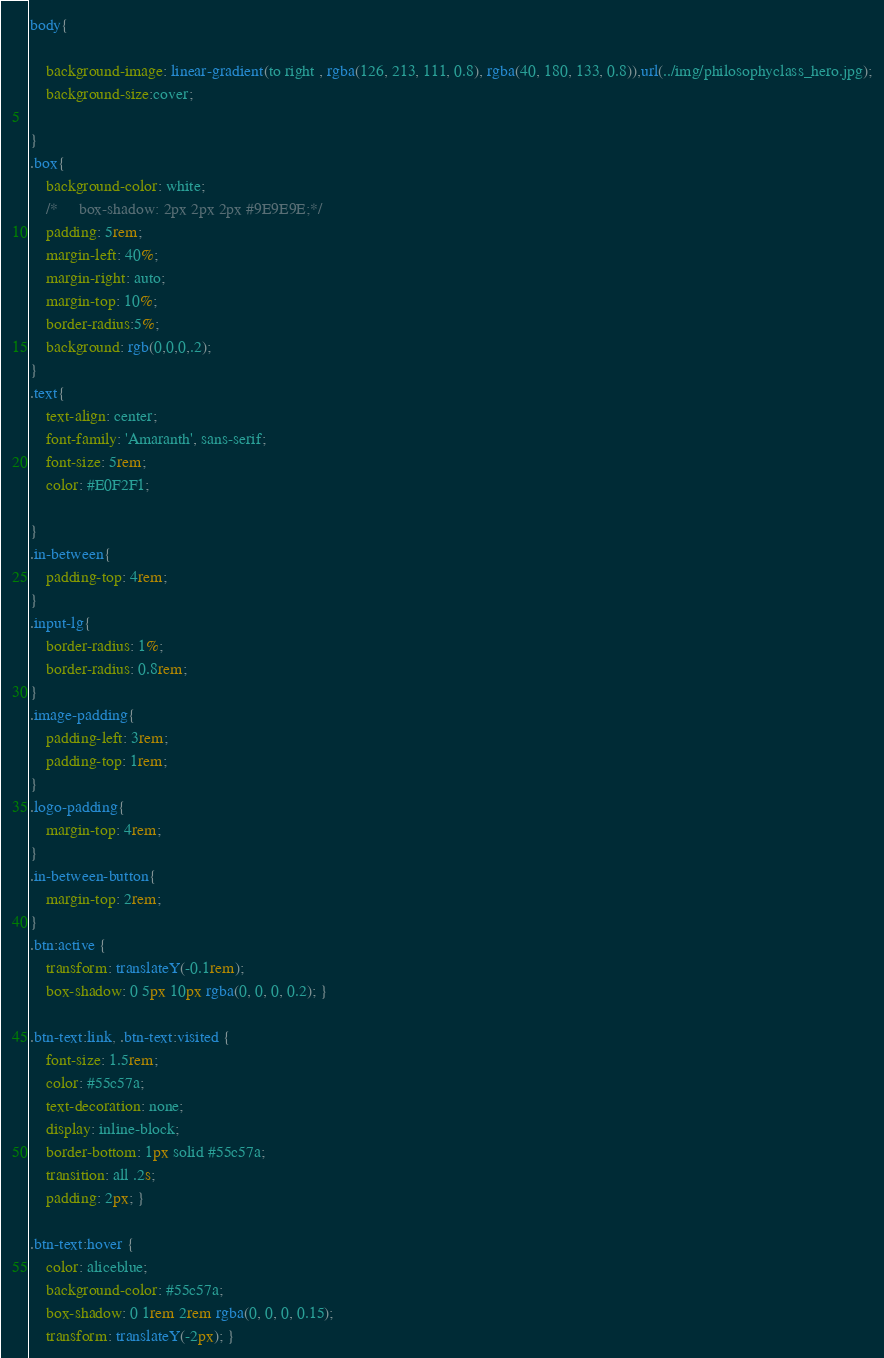<code> <loc_0><loc_0><loc_500><loc_500><_CSS_>body{

    background-image: linear-gradient(to right , rgba(126, 213, 111, 0.8), rgba(40, 180, 133, 0.8)),url(../img/philosophyclass_hero.jpg);
    background-size:cover;

}
.box{
    background-color: white;
    /*     box-shadow: 2px 2px 2px #9E9E9E;*/
    padding: 5rem;
    margin-left: 40%;
    margin-right: auto;
    margin-top: 10%;
    border-radius:5%;
    background: rgb(0,0,0,.2);
}
.text{
    text-align: center;
    font-family: 'Amaranth', sans-serif;
    font-size: 5rem;
    color: #E0F2F1;

}
.in-between{
    padding-top: 4rem;
}
.input-lg{
    border-radius: 1%;
    border-radius: 0.8rem;
}
.image-padding{
    padding-left: 3rem;
    padding-top: 1rem;
}
.logo-padding{
    margin-top: 4rem;
}
.in-between-button{
    margin-top: 2rem;
}
.btn:active {
    transform: translateY(-0.1rem);
    box-shadow: 0 5px 10px rgba(0, 0, 0, 0.2); }

.btn-text:link, .btn-text:visited {
    font-size: 1.5rem;
    color: #55c57a;
    text-decoration: none;
    display: inline-block;
    border-bottom: 1px solid #55c57a;
    transition: all .2s;
    padding: 2px; }

.btn-text:hover {
    color: aliceblue;
    background-color: #55c57a;
    box-shadow: 0 1rem 2rem rgba(0, 0, 0, 0.15);
    transform: translateY(-2px); }</code> 